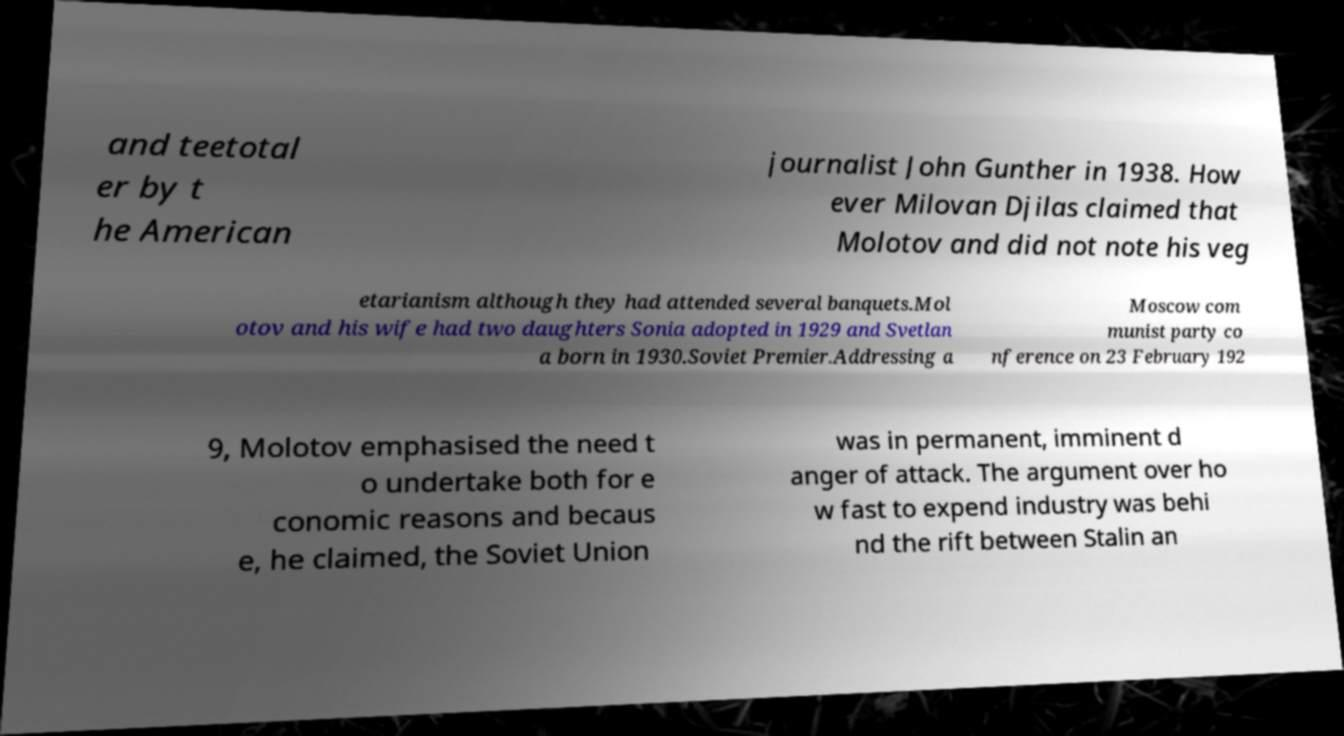Could you extract and type out the text from this image? and teetotal er by t he American journalist John Gunther in 1938. How ever Milovan Djilas claimed that Molotov and did not note his veg etarianism although they had attended several banquets.Mol otov and his wife had two daughters Sonia adopted in 1929 and Svetlan a born in 1930.Soviet Premier.Addressing a Moscow com munist party co nference on 23 February 192 9, Molotov emphasised the need t o undertake both for e conomic reasons and becaus e, he claimed, the Soviet Union was in permanent, imminent d anger of attack. The argument over ho w fast to expend industry was behi nd the rift between Stalin an 